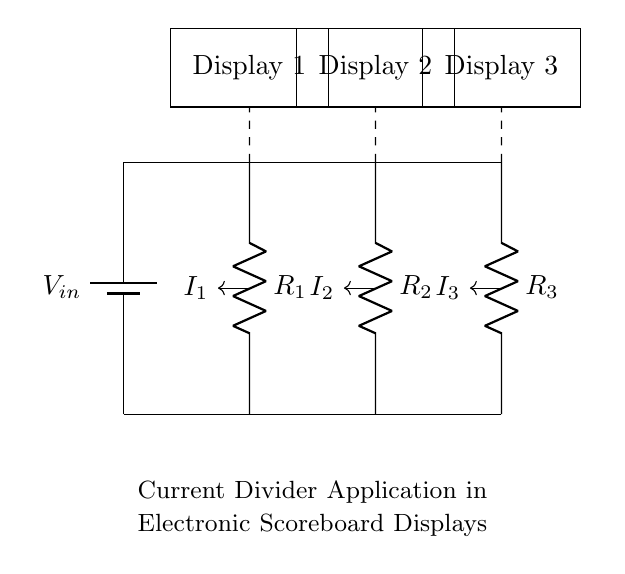What is the input voltage of this circuit? The input voltage is denoted as V_in, which represents the total voltage supplied to the circuit. This is the voltage supplied by the battery in the circuit.
Answer: V_in How many resistors are present in the circuit? There are three resistors present in the circuit, labeled as R_1, R_2, and R_3.
Answer: Three What is the purpose of the current divider in this circuit? The purpose of the current divider is to distribute the total current flowing from the input voltage across multiple branches with different resistors, allowing each display to receive a proportional amount of the total current based on the resistance of each branch.
Answer: To distribute current What is the current flowing through R_2? The current through each resistor can be determined using the current divider formula, which states that the current through any resistor in parallel is inversely proportional to its resistance. The specific value isn't given in the diagram, but it would depend on the input voltage and resistances.
Answer: Depends on input and resistances Which display is associated with resistor R_1? Display 1 is associated with resistor R_1, as indicated by the dashed line connecting R_1 to Display 1 in the circuit diagram.
Answer: Display 1 What type of circuit is demonstrated here? This circuit is a current divider circuit, specifically designed to split the input current into various branches corresponding to different displays based on their resistance values.
Answer: Current divider 